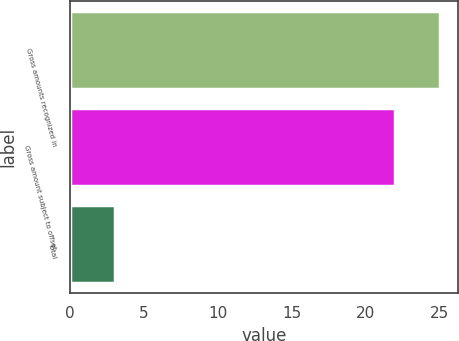Convert chart to OTSL. <chart><loc_0><loc_0><loc_500><loc_500><bar_chart><fcel>Gross amounts recognized in<fcel>Gross amount subject to offset<fcel>Total<nl><fcel>25<fcel>22<fcel>3<nl></chart> 